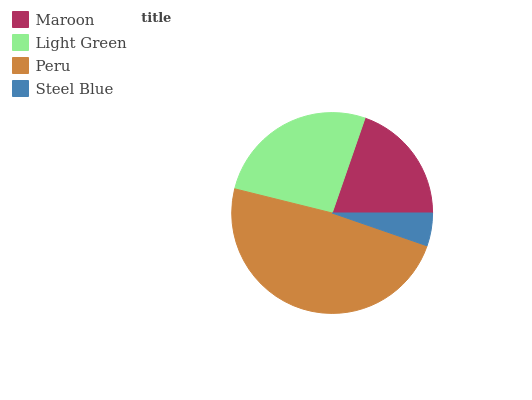Is Steel Blue the minimum?
Answer yes or no. Yes. Is Peru the maximum?
Answer yes or no. Yes. Is Light Green the minimum?
Answer yes or no. No. Is Light Green the maximum?
Answer yes or no. No. Is Light Green greater than Maroon?
Answer yes or no. Yes. Is Maroon less than Light Green?
Answer yes or no. Yes. Is Maroon greater than Light Green?
Answer yes or no. No. Is Light Green less than Maroon?
Answer yes or no. No. Is Light Green the high median?
Answer yes or no. Yes. Is Maroon the low median?
Answer yes or no. Yes. Is Peru the high median?
Answer yes or no. No. Is Peru the low median?
Answer yes or no. No. 